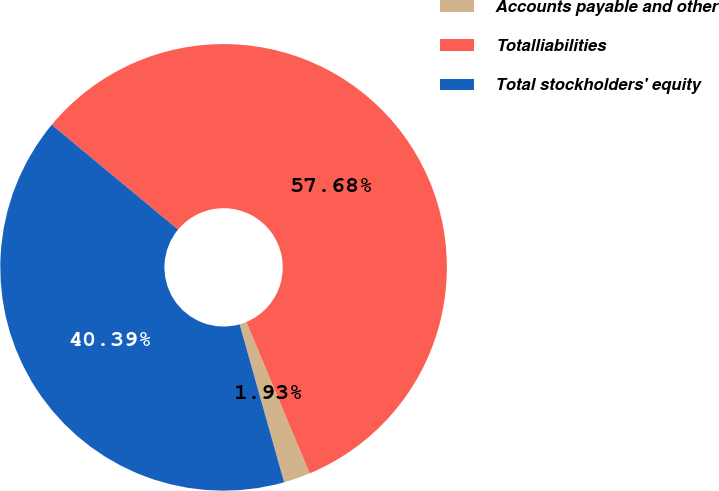Convert chart. <chart><loc_0><loc_0><loc_500><loc_500><pie_chart><fcel>Accounts payable and other<fcel>Totalliabilities<fcel>Total stockholders' equity<nl><fcel>1.93%<fcel>57.68%<fcel>40.39%<nl></chart> 